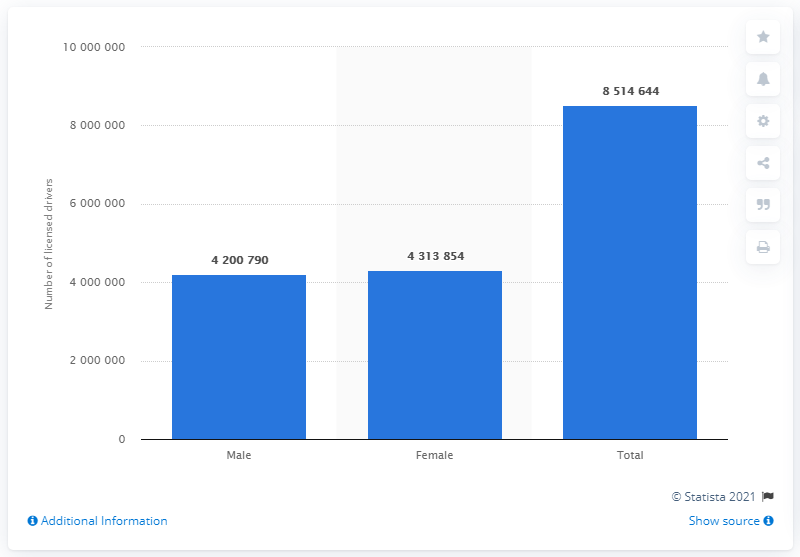List a handful of essential elements in this visual. In 2016, there were 431,385 female drivers on the roads in the state of Illinois. 